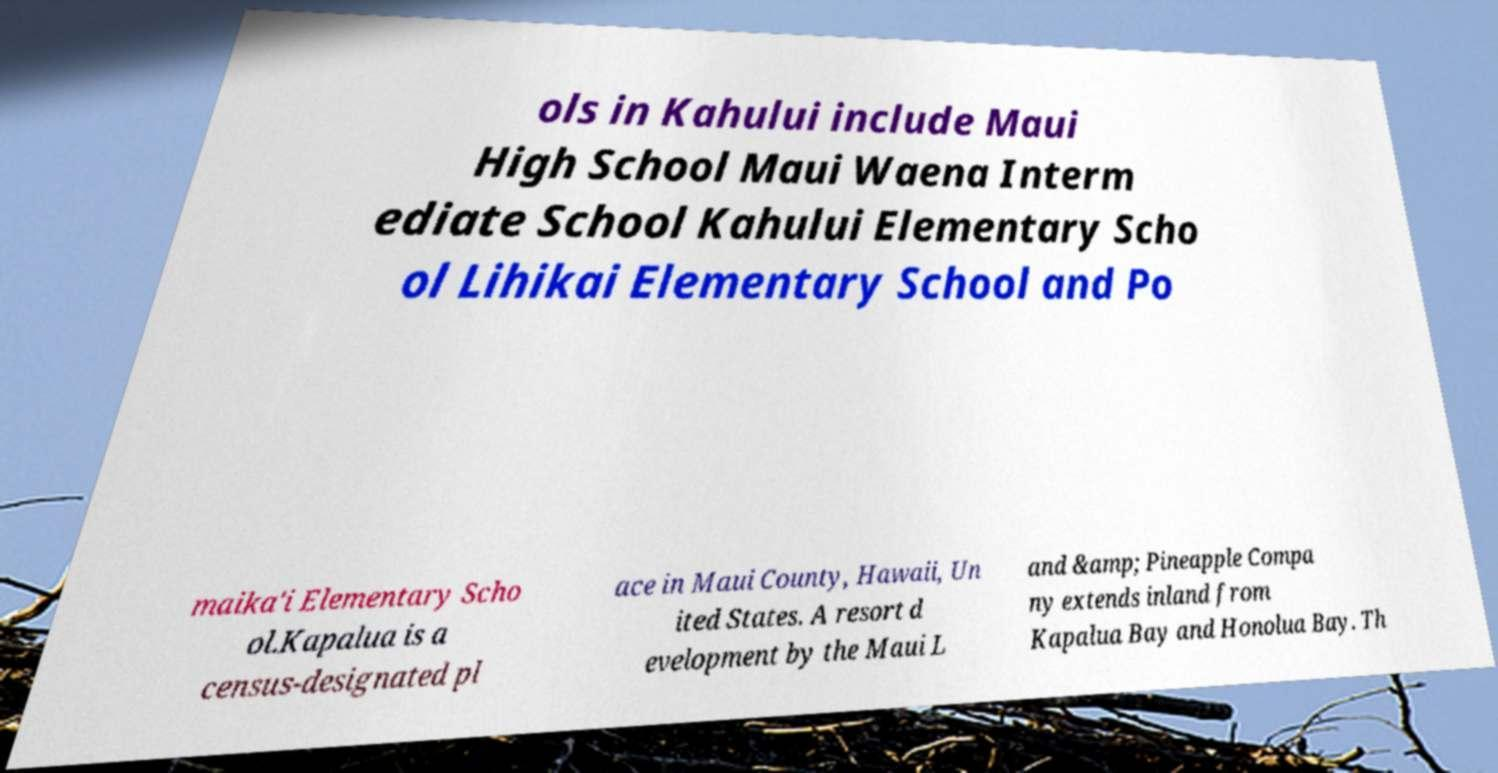What messages or text are displayed in this image? I need them in a readable, typed format. ols in Kahului include Maui High School Maui Waena Interm ediate School Kahului Elementary Scho ol Lihikai Elementary School and Po maika'i Elementary Scho ol.Kapalua is a census-designated pl ace in Maui County, Hawaii, Un ited States. A resort d evelopment by the Maui L and &amp; Pineapple Compa ny extends inland from Kapalua Bay and Honolua Bay. Th 